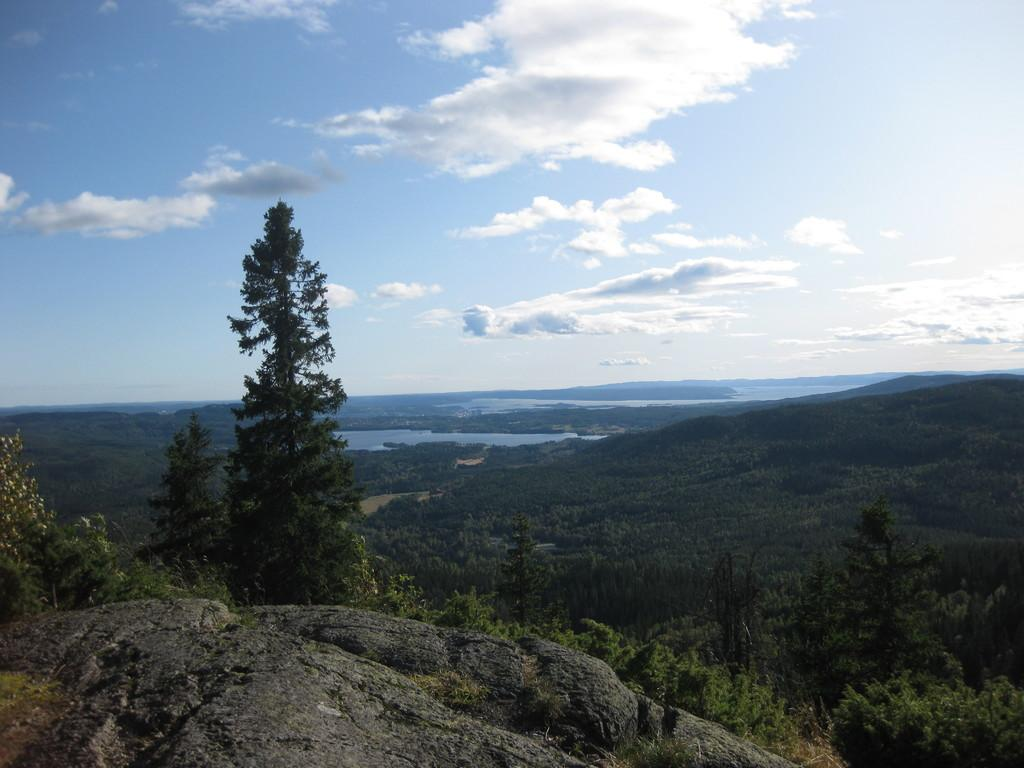What type of vegetation can be seen in the image? There are trees in the image. What geographical feature is present in the image? There is a hill in the image. What natural element is visible in the image? Water is visible in the image. What part of the natural environment is visible in the image? The sky is visible in the image. What atmospheric conditions can be observed in the sky? Clouds are present in the sky. What type of skin condition does the girl have in the image? There is no girl present in the image, so it is not possible to determine if anyone has a skin condition. What type of queen is depicted in the image? There is no queen present in the image. 